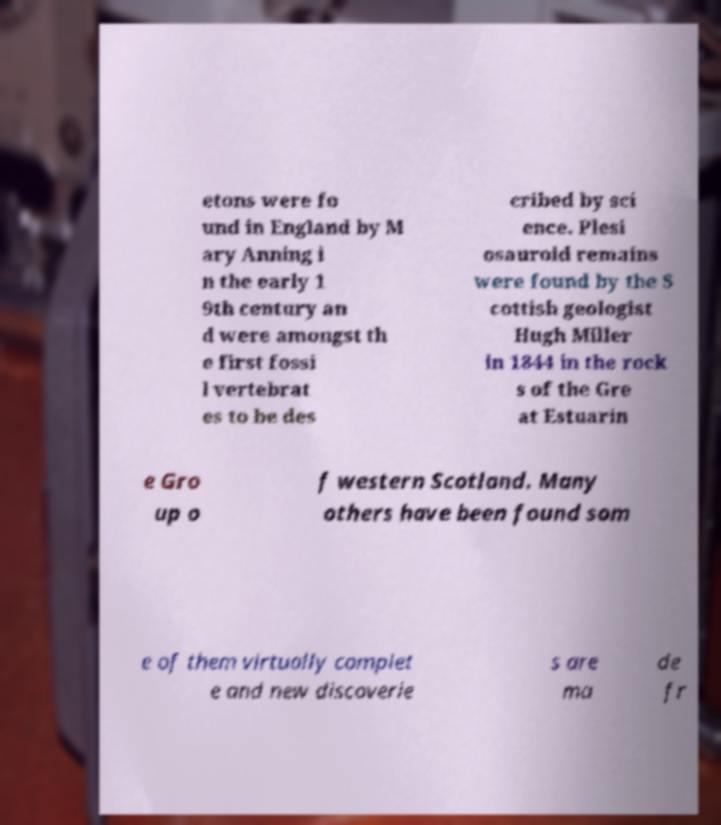There's text embedded in this image that I need extracted. Can you transcribe it verbatim? etons were fo und in England by M ary Anning i n the early 1 9th century an d were amongst th e first fossi l vertebrat es to be des cribed by sci ence. Plesi osauroid remains were found by the S cottish geologist Hugh Miller in 1844 in the rock s of the Gre at Estuarin e Gro up o f western Scotland. Many others have been found som e of them virtually complet e and new discoverie s are ma de fr 